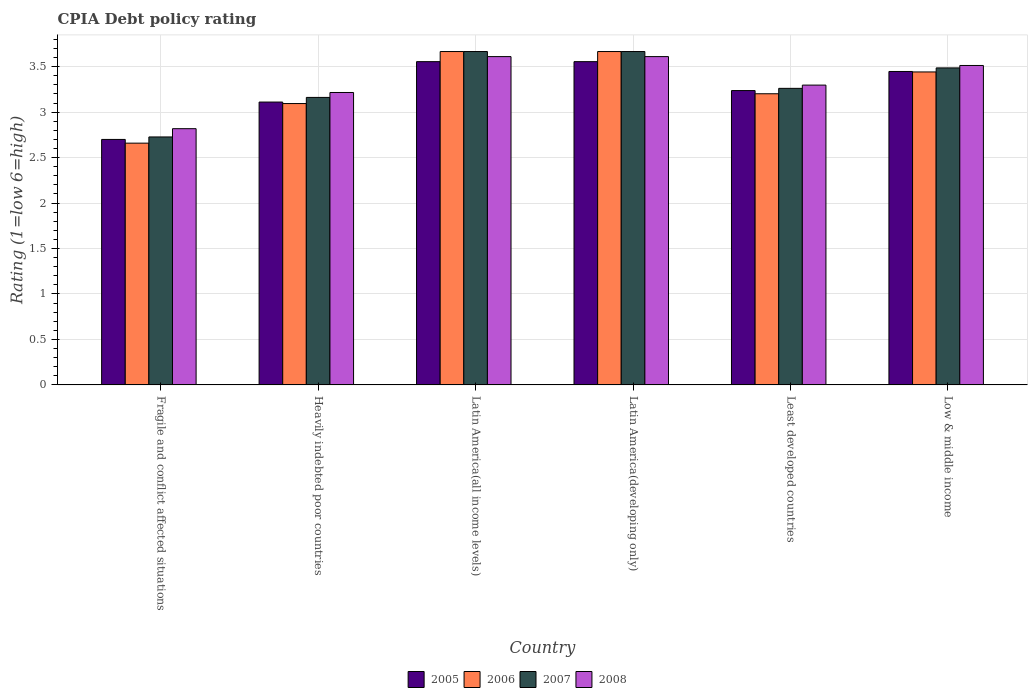How many groups of bars are there?
Give a very brief answer. 6. Are the number of bars per tick equal to the number of legend labels?
Keep it short and to the point. Yes. How many bars are there on the 1st tick from the left?
Your response must be concise. 4. What is the label of the 5th group of bars from the left?
Offer a terse response. Least developed countries. In how many cases, is the number of bars for a given country not equal to the number of legend labels?
Offer a very short reply. 0. What is the CPIA rating in 2006 in Heavily indebted poor countries?
Your answer should be compact. 3.09. Across all countries, what is the maximum CPIA rating in 2005?
Make the answer very short. 3.56. Across all countries, what is the minimum CPIA rating in 2007?
Provide a succinct answer. 2.73. In which country was the CPIA rating in 2008 maximum?
Provide a short and direct response. Latin America(all income levels). In which country was the CPIA rating in 2007 minimum?
Your response must be concise. Fragile and conflict affected situations. What is the total CPIA rating in 2008 in the graph?
Your answer should be compact. 20.07. What is the difference between the CPIA rating in 2007 in Latin America(all income levels) and that in Least developed countries?
Provide a succinct answer. 0.4. What is the difference between the CPIA rating in 2007 in Heavily indebted poor countries and the CPIA rating in 2006 in Fragile and conflict affected situations?
Provide a succinct answer. 0.5. What is the average CPIA rating in 2008 per country?
Offer a terse response. 3.34. What is the difference between the CPIA rating of/in 2006 and CPIA rating of/in 2005 in Least developed countries?
Your answer should be compact. -0.04. What is the ratio of the CPIA rating in 2005 in Heavily indebted poor countries to that in Latin America(developing only)?
Make the answer very short. 0.87. Is the CPIA rating in 2005 in Heavily indebted poor countries less than that in Latin America(developing only)?
Give a very brief answer. Yes. What is the difference between the highest and the second highest CPIA rating in 2008?
Provide a succinct answer. -0.1. What is the difference between the highest and the lowest CPIA rating in 2005?
Your response must be concise. 0.86. Is the sum of the CPIA rating in 2008 in Least developed countries and Low & middle income greater than the maximum CPIA rating in 2007 across all countries?
Your answer should be compact. Yes. Is it the case that in every country, the sum of the CPIA rating in 2008 and CPIA rating in 2007 is greater than the sum of CPIA rating in 2006 and CPIA rating in 2005?
Offer a very short reply. No. What does the 4th bar from the left in Low & middle income represents?
Make the answer very short. 2008. Are all the bars in the graph horizontal?
Your answer should be very brief. No. Are the values on the major ticks of Y-axis written in scientific E-notation?
Keep it short and to the point. No. Does the graph contain any zero values?
Give a very brief answer. No. Does the graph contain grids?
Make the answer very short. Yes. How many legend labels are there?
Offer a very short reply. 4. What is the title of the graph?
Offer a terse response. CPIA Debt policy rating. Does "1979" appear as one of the legend labels in the graph?
Ensure brevity in your answer.  No. What is the Rating (1=low 6=high) of 2006 in Fragile and conflict affected situations?
Provide a succinct answer. 2.66. What is the Rating (1=low 6=high) in 2007 in Fragile and conflict affected situations?
Ensure brevity in your answer.  2.73. What is the Rating (1=low 6=high) of 2008 in Fragile and conflict affected situations?
Offer a terse response. 2.82. What is the Rating (1=low 6=high) of 2005 in Heavily indebted poor countries?
Your response must be concise. 3.11. What is the Rating (1=low 6=high) of 2006 in Heavily indebted poor countries?
Offer a very short reply. 3.09. What is the Rating (1=low 6=high) of 2007 in Heavily indebted poor countries?
Offer a terse response. 3.16. What is the Rating (1=low 6=high) of 2008 in Heavily indebted poor countries?
Offer a very short reply. 3.22. What is the Rating (1=low 6=high) of 2005 in Latin America(all income levels)?
Provide a succinct answer. 3.56. What is the Rating (1=low 6=high) in 2006 in Latin America(all income levels)?
Make the answer very short. 3.67. What is the Rating (1=low 6=high) in 2007 in Latin America(all income levels)?
Your answer should be very brief. 3.67. What is the Rating (1=low 6=high) in 2008 in Latin America(all income levels)?
Provide a short and direct response. 3.61. What is the Rating (1=low 6=high) in 2005 in Latin America(developing only)?
Your answer should be very brief. 3.56. What is the Rating (1=low 6=high) of 2006 in Latin America(developing only)?
Your answer should be very brief. 3.67. What is the Rating (1=low 6=high) of 2007 in Latin America(developing only)?
Offer a terse response. 3.67. What is the Rating (1=low 6=high) of 2008 in Latin America(developing only)?
Your answer should be compact. 3.61. What is the Rating (1=low 6=high) in 2005 in Least developed countries?
Your answer should be compact. 3.24. What is the Rating (1=low 6=high) of 2006 in Least developed countries?
Your response must be concise. 3.2. What is the Rating (1=low 6=high) in 2007 in Least developed countries?
Keep it short and to the point. 3.26. What is the Rating (1=low 6=high) of 2008 in Least developed countries?
Offer a terse response. 3.3. What is the Rating (1=low 6=high) in 2005 in Low & middle income?
Ensure brevity in your answer.  3.45. What is the Rating (1=low 6=high) of 2006 in Low & middle income?
Your answer should be compact. 3.44. What is the Rating (1=low 6=high) in 2007 in Low & middle income?
Your response must be concise. 3.49. What is the Rating (1=low 6=high) of 2008 in Low & middle income?
Offer a very short reply. 3.51. Across all countries, what is the maximum Rating (1=low 6=high) in 2005?
Ensure brevity in your answer.  3.56. Across all countries, what is the maximum Rating (1=low 6=high) in 2006?
Provide a succinct answer. 3.67. Across all countries, what is the maximum Rating (1=low 6=high) of 2007?
Provide a succinct answer. 3.67. Across all countries, what is the maximum Rating (1=low 6=high) of 2008?
Offer a terse response. 3.61. Across all countries, what is the minimum Rating (1=low 6=high) in 2006?
Provide a short and direct response. 2.66. Across all countries, what is the minimum Rating (1=low 6=high) of 2007?
Your response must be concise. 2.73. Across all countries, what is the minimum Rating (1=low 6=high) of 2008?
Ensure brevity in your answer.  2.82. What is the total Rating (1=low 6=high) in 2005 in the graph?
Provide a short and direct response. 19.61. What is the total Rating (1=low 6=high) of 2006 in the graph?
Give a very brief answer. 19.73. What is the total Rating (1=low 6=high) in 2007 in the graph?
Give a very brief answer. 19.97. What is the total Rating (1=low 6=high) in 2008 in the graph?
Your response must be concise. 20.07. What is the difference between the Rating (1=low 6=high) in 2005 in Fragile and conflict affected situations and that in Heavily indebted poor countries?
Keep it short and to the point. -0.41. What is the difference between the Rating (1=low 6=high) in 2006 in Fragile and conflict affected situations and that in Heavily indebted poor countries?
Offer a very short reply. -0.44. What is the difference between the Rating (1=low 6=high) in 2007 in Fragile and conflict affected situations and that in Heavily indebted poor countries?
Keep it short and to the point. -0.43. What is the difference between the Rating (1=low 6=high) of 2008 in Fragile and conflict affected situations and that in Heavily indebted poor countries?
Your answer should be compact. -0.4. What is the difference between the Rating (1=low 6=high) in 2005 in Fragile and conflict affected situations and that in Latin America(all income levels)?
Your answer should be compact. -0.86. What is the difference between the Rating (1=low 6=high) of 2006 in Fragile and conflict affected situations and that in Latin America(all income levels)?
Keep it short and to the point. -1.01. What is the difference between the Rating (1=low 6=high) in 2007 in Fragile and conflict affected situations and that in Latin America(all income levels)?
Keep it short and to the point. -0.94. What is the difference between the Rating (1=low 6=high) in 2008 in Fragile and conflict affected situations and that in Latin America(all income levels)?
Give a very brief answer. -0.79. What is the difference between the Rating (1=low 6=high) in 2005 in Fragile and conflict affected situations and that in Latin America(developing only)?
Provide a succinct answer. -0.86. What is the difference between the Rating (1=low 6=high) of 2006 in Fragile and conflict affected situations and that in Latin America(developing only)?
Give a very brief answer. -1.01. What is the difference between the Rating (1=low 6=high) in 2007 in Fragile and conflict affected situations and that in Latin America(developing only)?
Provide a succinct answer. -0.94. What is the difference between the Rating (1=low 6=high) of 2008 in Fragile and conflict affected situations and that in Latin America(developing only)?
Offer a very short reply. -0.79. What is the difference between the Rating (1=low 6=high) in 2005 in Fragile and conflict affected situations and that in Least developed countries?
Keep it short and to the point. -0.54. What is the difference between the Rating (1=low 6=high) of 2006 in Fragile and conflict affected situations and that in Least developed countries?
Your answer should be very brief. -0.54. What is the difference between the Rating (1=low 6=high) in 2007 in Fragile and conflict affected situations and that in Least developed countries?
Your response must be concise. -0.53. What is the difference between the Rating (1=low 6=high) of 2008 in Fragile and conflict affected situations and that in Least developed countries?
Your answer should be very brief. -0.48. What is the difference between the Rating (1=low 6=high) in 2005 in Fragile and conflict affected situations and that in Low & middle income?
Your answer should be compact. -0.75. What is the difference between the Rating (1=low 6=high) of 2006 in Fragile and conflict affected situations and that in Low & middle income?
Offer a terse response. -0.78. What is the difference between the Rating (1=low 6=high) in 2007 in Fragile and conflict affected situations and that in Low & middle income?
Offer a very short reply. -0.76. What is the difference between the Rating (1=low 6=high) in 2008 in Fragile and conflict affected situations and that in Low & middle income?
Give a very brief answer. -0.7. What is the difference between the Rating (1=low 6=high) of 2005 in Heavily indebted poor countries and that in Latin America(all income levels)?
Ensure brevity in your answer.  -0.44. What is the difference between the Rating (1=low 6=high) in 2006 in Heavily indebted poor countries and that in Latin America(all income levels)?
Your response must be concise. -0.57. What is the difference between the Rating (1=low 6=high) in 2007 in Heavily indebted poor countries and that in Latin America(all income levels)?
Your response must be concise. -0.5. What is the difference between the Rating (1=low 6=high) in 2008 in Heavily indebted poor countries and that in Latin America(all income levels)?
Keep it short and to the point. -0.39. What is the difference between the Rating (1=low 6=high) in 2005 in Heavily indebted poor countries and that in Latin America(developing only)?
Offer a very short reply. -0.44. What is the difference between the Rating (1=low 6=high) in 2006 in Heavily indebted poor countries and that in Latin America(developing only)?
Give a very brief answer. -0.57. What is the difference between the Rating (1=low 6=high) of 2007 in Heavily indebted poor countries and that in Latin America(developing only)?
Offer a terse response. -0.5. What is the difference between the Rating (1=low 6=high) in 2008 in Heavily indebted poor countries and that in Latin America(developing only)?
Ensure brevity in your answer.  -0.39. What is the difference between the Rating (1=low 6=high) of 2005 in Heavily indebted poor countries and that in Least developed countries?
Ensure brevity in your answer.  -0.13. What is the difference between the Rating (1=low 6=high) of 2006 in Heavily indebted poor countries and that in Least developed countries?
Your response must be concise. -0.11. What is the difference between the Rating (1=low 6=high) of 2007 in Heavily indebted poor countries and that in Least developed countries?
Offer a very short reply. -0.1. What is the difference between the Rating (1=low 6=high) in 2008 in Heavily indebted poor countries and that in Least developed countries?
Ensure brevity in your answer.  -0.08. What is the difference between the Rating (1=low 6=high) of 2005 in Heavily indebted poor countries and that in Low & middle income?
Provide a short and direct response. -0.34. What is the difference between the Rating (1=low 6=high) in 2006 in Heavily indebted poor countries and that in Low & middle income?
Ensure brevity in your answer.  -0.35. What is the difference between the Rating (1=low 6=high) of 2007 in Heavily indebted poor countries and that in Low & middle income?
Provide a short and direct response. -0.32. What is the difference between the Rating (1=low 6=high) in 2008 in Heavily indebted poor countries and that in Low & middle income?
Provide a succinct answer. -0.3. What is the difference between the Rating (1=low 6=high) in 2006 in Latin America(all income levels) and that in Latin America(developing only)?
Ensure brevity in your answer.  0. What is the difference between the Rating (1=low 6=high) in 2005 in Latin America(all income levels) and that in Least developed countries?
Keep it short and to the point. 0.32. What is the difference between the Rating (1=low 6=high) of 2006 in Latin America(all income levels) and that in Least developed countries?
Ensure brevity in your answer.  0.46. What is the difference between the Rating (1=low 6=high) in 2007 in Latin America(all income levels) and that in Least developed countries?
Your response must be concise. 0.4. What is the difference between the Rating (1=low 6=high) in 2008 in Latin America(all income levels) and that in Least developed countries?
Keep it short and to the point. 0.31. What is the difference between the Rating (1=low 6=high) in 2005 in Latin America(all income levels) and that in Low & middle income?
Your answer should be compact. 0.11. What is the difference between the Rating (1=low 6=high) of 2006 in Latin America(all income levels) and that in Low & middle income?
Offer a terse response. 0.22. What is the difference between the Rating (1=low 6=high) of 2007 in Latin America(all income levels) and that in Low & middle income?
Provide a short and direct response. 0.18. What is the difference between the Rating (1=low 6=high) of 2008 in Latin America(all income levels) and that in Low & middle income?
Make the answer very short. 0.1. What is the difference between the Rating (1=low 6=high) in 2005 in Latin America(developing only) and that in Least developed countries?
Give a very brief answer. 0.32. What is the difference between the Rating (1=low 6=high) in 2006 in Latin America(developing only) and that in Least developed countries?
Offer a terse response. 0.46. What is the difference between the Rating (1=low 6=high) of 2007 in Latin America(developing only) and that in Least developed countries?
Your response must be concise. 0.4. What is the difference between the Rating (1=low 6=high) in 2008 in Latin America(developing only) and that in Least developed countries?
Your answer should be very brief. 0.31. What is the difference between the Rating (1=low 6=high) of 2005 in Latin America(developing only) and that in Low & middle income?
Offer a very short reply. 0.11. What is the difference between the Rating (1=low 6=high) of 2006 in Latin America(developing only) and that in Low & middle income?
Your answer should be very brief. 0.22. What is the difference between the Rating (1=low 6=high) in 2007 in Latin America(developing only) and that in Low & middle income?
Your answer should be compact. 0.18. What is the difference between the Rating (1=low 6=high) of 2008 in Latin America(developing only) and that in Low & middle income?
Give a very brief answer. 0.1. What is the difference between the Rating (1=low 6=high) of 2005 in Least developed countries and that in Low & middle income?
Ensure brevity in your answer.  -0.21. What is the difference between the Rating (1=low 6=high) in 2006 in Least developed countries and that in Low & middle income?
Provide a succinct answer. -0.24. What is the difference between the Rating (1=low 6=high) of 2007 in Least developed countries and that in Low & middle income?
Provide a succinct answer. -0.22. What is the difference between the Rating (1=low 6=high) in 2008 in Least developed countries and that in Low & middle income?
Offer a terse response. -0.22. What is the difference between the Rating (1=low 6=high) in 2005 in Fragile and conflict affected situations and the Rating (1=low 6=high) in 2006 in Heavily indebted poor countries?
Provide a short and direct response. -0.39. What is the difference between the Rating (1=low 6=high) in 2005 in Fragile and conflict affected situations and the Rating (1=low 6=high) in 2007 in Heavily indebted poor countries?
Provide a succinct answer. -0.46. What is the difference between the Rating (1=low 6=high) in 2005 in Fragile and conflict affected situations and the Rating (1=low 6=high) in 2008 in Heavily indebted poor countries?
Your answer should be compact. -0.52. What is the difference between the Rating (1=low 6=high) of 2006 in Fragile and conflict affected situations and the Rating (1=low 6=high) of 2007 in Heavily indebted poor countries?
Keep it short and to the point. -0.5. What is the difference between the Rating (1=low 6=high) in 2006 in Fragile and conflict affected situations and the Rating (1=low 6=high) in 2008 in Heavily indebted poor countries?
Offer a very short reply. -0.56. What is the difference between the Rating (1=low 6=high) in 2007 in Fragile and conflict affected situations and the Rating (1=low 6=high) in 2008 in Heavily indebted poor countries?
Keep it short and to the point. -0.49. What is the difference between the Rating (1=low 6=high) of 2005 in Fragile and conflict affected situations and the Rating (1=low 6=high) of 2006 in Latin America(all income levels)?
Offer a terse response. -0.97. What is the difference between the Rating (1=low 6=high) in 2005 in Fragile and conflict affected situations and the Rating (1=low 6=high) in 2007 in Latin America(all income levels)?
Offer a very short reply. -0.97. What is the difference between the Rating (1=low 6=high) of 2005 in Fragile and conflict affected situations and the Rating (1=low 6=high) of 2008 in Latin America(all income levels)?
Give a very brief answer. -0.91. What is the difference between the Rating (1=low 6=high) of 2006 in Fragile and conflict affected situations and the Rating (1=low 6=high) of 2007 in Latin America(all income levels)?
Keep it short and to the point. -1.01. What is the difference between the Rating (1=low 6=high) in 2006 in Fragile and conflict affected situations and the Rating (1=low 6=high) in 2008 in Latin America(all income levels)?
Provide a short and direct response. -0.95. What is the difference between the Rating (1=low 6=high) in 2007 in Fragile and conflict affected situations and the Rating (1=low 6=high) in 2008 in Latin America(all income levels)?
Provide a succinct answer. -0.88. What is the difference between the Rating (1=low 6=high) of 2005 in Fragile and conflict affected situations and the Rating (1=low 6=high) of 2006 in Latin America(developing only)?
Make the answer very short. -0.97. What is the difference between the Rating (1=low 6=high) in 2005 in Fragile and conflict affected situations and the Rating (1=low 6=high) in 2007 in Latin America(developing only)?
Your answer should be very brief. -0.97. What is the difference between the Rating (1=low 6=high) in 2005 in Fragile and conflict affected situations and the Rating (1=low 6=high) in 2008 in Latin America(developing only)?
Keep it short and to the point. -0.91. What is the difference between the Rating (1=low 6=high) in 2006 in Fragile and conflict affected situations and the Rating (1=low 6=high) in 2007 in Latin America(developing only)?
Ensure brevity in your answer.  -1.01. What is the difference between the Rating (1=low 6=high) in 2006 in Fragile and conflict affected situations and the Rating (1=low 6=high) in 2008 in Latin America(developing only)?
Your response must be concise. -0.95. What is the difference between the Rating (1=low 6=high) in 2007 in Fragile and conflict affected situations and the Rating (1=low 6=high) in 2008 in Latin America(developing only)?
Your answer should be compact. -0.88. What is the difference between the Rating (1=low 6=high) of 2005 in Fragile and conflict affected situations and the Rating (1=low 6=high) of 2006 in Least developed countries?
Provide a short and direct response. -0.5. What is the difference between the Rating (1=low 6=high) in 2005 in Fragile and conflict affected situations and the Rating (1=low 6=high) in 2007 in Least developed countries?
Your answer should be very brief. -0.56. What is the difference between the Rating (1=low 6=high) of 2005 in Fragile and conflict affected situations and the Rating (1=low 6=high) of 2008 in Least developed countries?
Your answer should be compact. -0.6. What is the difference between the Rating (1=low 6=high) of 2006 in Fragile and conflict affected situations and the Rating (1=low 6=high) of 2007 in Least developed countries?
Ensure brevity in your answer.  -0.6. What is the difference between the Rating (1=low 6=high) in 2006 in Fragile and conflict affected situations and the Rating (1=low 6=high) in 2008 in Least developed countries?
Keep it short and to the point. -0.64. What is the difference between the Rating (1=low 6=high) in 2007 in Fragile and conflict affected situations and the Rating (1=low 6=high) in 2008 in Least developed countries?
Make the answer very short. -0.57. What is the difference between the Rating (1=low 6=high) of 2005 in Fragile and conflict affected situations and the Rating (1=low 6=high) of 2006 in Low & middle income?
Keep it short and to the point. -0.74. What is the difference between the Rating (1=low 6=high) of 2005 in Fragile and conflict affected situations and the Rating (1=low 6=high) of 2007 in Low & middle income?
Ensure brevity in your answer.  -0.79. What is the difference between the Rating (1=low 6=high) in 2005 in Fragile and conflict affected situations and the Rating (1=low 6=high) in 2008 in Low & middle income?
Give a very brief answer. -0.81. What is the difference between the Rating (1=low 6=high) in 2006 in Fragile and conflict affected situations and the Rating (1=low 6=high) in 2007 in Low & middle income?
Offer a terse response. -0.83. What is the difference between the Rating (1=low 6=high) of 2006 in Fragile and conflict affected situations and the Rating (1=low 6=high) of 2008 in Low & middle income?
Keep it short and to the point. -0.85. What is the difference between the Rating (1=low 6=high) in 2007 in Fragile and conflict affected situations and the Rating (1=low 6=high) in 2008 in Low & middle income?
Your answer should be very brief. -0.79. What is the difference between the Rating (1=low 6=high) in 2005 in Heavily indebted poor countries and the Rating (1=low 6=high) in 2006 in Latin America(all income levels)?
Ensure brevity in your answer.  -0.56. What is the difference between the Rating (1=low 6=high) of 2005 in Heavily indebted poor countries and the Rating (1=low 6=high) of 2007 in Latin America(all income levels)?
Make the answer very short. -0.56. What is the difference between the Rating (1=low 6=high) in 2006 in Heavily indebted poor countries and the Rating (1=low 6=high) in 2007 in Latin America(all income levels)?
Offer a very short reply. -0.57. What is the difference between the Rating (1=low 6=high) in 2006 in Heavily indebted poor countries and the Rating (1=low 6=high) in 2008 in Latin America(all income levels)?
Provide a short and direct response. -0.52. What is the difference between the Rating (1=low 6=high) of 2007 in Heavily indebted poor countries and the Rating (1=low 6=high) of 2008 in Latin America(all income levels)?
Provide a short and direct response. -0.45. What is the difference between the Rating (1=low 6=high) in 2005 in Heavily indebted poor countries and the Rating (1=low 6=high) in 2006 in Latin America(developing only)?
Provide a succinct answer. -0.56. What is the difference between the Rating (1=low 6=high) in 2005 in Heavily indebted poor countries and the Rating (1=low 6=high) in 2007 in Latin America(developing only)?
Give a very brief answer. -0.56. What is the difference between the Rating (1=low 6=high) of 2006 in Heavily indebted poor countries and the Rating (1=low 6=high) of 2007 in Latin America(developing only)?
Your answer should be compact. -0.57. What is the difference between the Rating (1=low 6=high) of 2006 in Heavily indebted poor countries and the Rating (1=low 6=high) of 2008 in Latin America(developing only)?
Your answer should be compact. -0.52. What is the difference between the Rating (1=low 6=high) in 2007 in Heavily indebted poor countries and the Rating (1=low 6=high) in 2008 in Latin America(developing only)?
Your answer should be compact. -0.45. What is the difference between the Rating (1=low 6=high) in 2005 in Heavily indebted poor countries and the Rating (1=low 6=high) in 2006 in Least developed countries?
Ensure brevity in your answer.  -0.09. What is the difference between the Rating (1=low 6=high) in 2005 in Heavily indebted poor countries and the Rating (1=low 6=high) in 2007 in Least developed countries?
Your answer should be compact. -0.15. What is the difference between the Rating (1=low 6=high) of 2005 in Heavily indebted poor countries and the Rating (1=low 6=high) of 2008 in Least developed countries?
Make the answer very short. -0.19. What is the difference between the Rating (1=low 6=high) of 2006 in Heavily indebted poor countries and the Rating (1=low 6=high) of 2007 in Least developed countries?
Your answer should be compact. -0.17. What is the difference between the Rating (1=low 6=high) of 2006 in Heavily indebted poor countries and the Rating (1=low 6=high) of 2008 in Least developed countries?
Your answer should be compact. -0.2. What is the difference between the Rating (1=low 6=high) in 2007 in Heavily indebted poor countries and the Rating (1=low 6=high) in 2008 in Least developed countries?
Make the answer very short. -0.14. What is the difference between the Rating (1=low 6=high) in 2005 in Heavily indebted poor countries and the Rating (1=low 6=high) in 2006 in Low & middle income?
Provide a short and direct response. -0.33. What is the difference between the Rating (1=low 6=high) of 2005 in Heavily indebted poor countries and the Rating (1=low 6=high) of 2007 in Low & middle income?
Make the answer very short. -0.38. What is the difference between the Rating (1=low 6=high) of 2005 in Heavily indebted poor countries and the Rating (1=low 6=high) of 2008 in Low & middle income?
Give a very brief answer. -0.4. What is the difference between the Rating (1=low 6=high) of 2006 in Heavily indebted poor countries and the Rating (1=low 6=high) of 2007 in Low & middle income?
Ensure brevity in your answer.  -0.39. What is the difference between the Rating (1=low 6=high) of 2006 in Heavily indebted poor countries and the Rating (1=low 6=high) of 2008 in Low & middle income?
Your answer should be compact. -0.42. What is the difference between the Rating (1=low 6=high) in 2007 in Heavily indebted poor countries and the Rating (1=low 6=high) in 2008 in Low & middle income?
Make the answer very short. -0.35. What is the difference between the Rating (1=low 6=high) in 2005 in Latin America(all income levels) and the Rating (1=low 6=high) in 2006 in Latin America(developing only)?
Your answer should be compact. -0.11. What is the difference between the Rating (1=low 6=high) of 2005 in Latin America(all income levels) and the Rating (1=low 6=high) of 2007 in Latin America(developing only)?
Provide a short and direct response. -0.11. What is the difference between the Rating (1=low 6=high) in 2005 in Latin America(all income levels) and the Rating (1=low 6=high) in 2008 in Latin America(developing only)?
Provide a short and direct response. -0.06. What is the difference between the Rating (1=low 6=high) in 2006 in Latin America(all income levels) and the Rating (1=low 6=high) in 2007 in Latin America(developing only)?
Provide a succinct answer. 0. What is the difference between the Rating (1=low 6=high) in 2006 in Latin America(all income levels) and the Rating (1=low 6=high) in 2008 in Latin America(developing only)?
Offer a terse response. 0.06. What is the difference between the Rating (1=low 6=high) in 2007 in Latin America(all income levels) and the Rating (1=low 6=high) in 2008 in Latin America(developing only)?
Ensure brevity in your answer.  0.06. What is the difference between the Rating (1=low 6=high) in 2005 in Latin America(all income levels) and the Rating (1=low 6=high) in 2006 in Least developed countries?
Ensure brevity in your answer.  0.35. What is the difference between the Rating (1=low 6=high) of 2005 in Latin America(all income levels) and the Rating (1=low 6=high) of 2007 in Least developed countries?
Give a very brief answer. 0.29. What is the difference between the Rating (1=low 6=high) in 2005 in Latin America(all income levels) and the Rating (1=low 6=high) in 2008 in Least developed countries?
Keep it short and to the point. 0.26. What is the difference between the Rating (1=low 6=high) of 2006 in Latin America(all income levels) and the Rating (1=low 6=high) of 2007 in Least developed countries?
Make the answer very short. 0.4. What is the difference between the Rating (1=low 6=high) of 2006 in Latin America(all income levels) and the Rating (1=low 6=high) of 2008 in Least developed countries?
Keep it short and to the point. 0.37. What is the difference between the Rating (1=low 6=high) of 2007 in Latin America(all income levels) and the Rating (1=low 6=high) of 2008 in Least developed countries?
Your answer should be compact. 0.37. What is the difference between the Rating (1=low 6=high) of 2005 in Latin America(all income levels) and the Rating (1=low 6=high) of 2006 in Low & middle income?
Provide a short and direct response. 0.11. What is the difference between the Rating (1=low 6=high) of 2005 in Latin America(all income levels) and the Rating (1=low 6=high) of 2007 in Low & middle income?
Give a very brief answer. 0.07. What is the difference between the Rating (1=low 6=high) in 2005 in Latin America(all income levels) and the Rating (1=low 6=high) in 2008 in Low & middle income?
Your answer should be very brief. 0.04. What is the difference between the Rating (1=low 6=high) in 2006 in Latin America(all income levels) and the Rating (1=low 6=high) in 2007 in Low & middle income?
Provide a short and direct response. 0.18. What is the difference between the Rating (1=low 6=high) of 2006 in Latin America(all income levels) and the Rating (1=low 6=high) of 2008 in Low & middle income?
Offer a very short reply. 0.15. What is the difference between the Rating (1=low 6=high) of 2007 in Latin America(all income levels) and the Rating (1=low 6=high) of 2008 in Low & middle income?
Your answer should be compact. 0.15. What is the difference between the Rating (1=low 6=high) of 2005 in Latin America(developing only) and the Rating (1=low 6=high) of 2006 in Least developed countries?
Ensure brevity in your answer.  0.35. What is the difference between the Rating (1=low 6=high) of 2005 in Latin America(developing only) and the Rating (1=low 6=high) of 2007 in Least developed countries?
Offer a terse response. 0.29. What is the difference between the Rating (1=low 6=high) of 2005 in Latin America(developing only) and the Rating (1=low 6=high) of 2008 in Least developed countries?
Your answer should be compact. 0.26. What is the difference between the Rating (1=low 6=high) in 2006 in Latin America(developing only) and the Rating (1=low 6=high) in 2007 in Least developed countries?
Your answer should be compact. 0.4. What is the difference between the Rating (1=low 6=high) of 2006 in Latin America(developing only) and the Rating (1=low 6=high) of 2008 in Least developed countries?
Your answer should be compact. 0.37. What is the difference between the Rating (1=low 6=high) of 2007 in Latin America(developing only) and the Rating (1=low 6=high) of 2008 in Least developed countries?
Your answer should be compact. 0.37. What is the difference between the Rating (1=low 6=high) of 2005 in Latin America(developing only) and the Rating (1=low 6=high) of 2006 in Low & middle income?
Ensure brevity in your answer.  0.11. What is the difference between the Rating (1=low 6=high) of 2005 in Latin America(developing only) and the Rating (1=low 6=high) of 2007 in Low & middle income?
Make the answer very short. 0.07. What is the difference between the Rating (1=low 6=high) in 2005 in Latin America(developing only) and the Rating (1=low 6=high) in 2008 in Low & middle income?
Your answer should be compact. 0.04. What is the difference between the Rating (1=low 6=high) in 2006 in Latin America(developing only) and the Rating (1=low 6=high) in 2007 in Low & middle income?
Provide a succinct answer. 0.18. What is the difference between the Rating (1=low 6=high) in 2006 in Latin America(developing only) and the Rating (1=low 6=high) in 2008 in Low & middle income?
Offer a very short reply. 0.15. What is the difference between the Rating (1=low 6=high) in 2007 in Latin America(developing only) and the Rating (1=low 6=high) in 2008 in Low & middle income?
Your answer should be very brief. 0.15. What is the difference between the Rating (1=low 6=high) of 2005 in Least developed countries and the Rating (1=low 6=high) of 2006 in Low & middle income?
Ensure brevity in your answer.  -0.2. What is the difference between the Rating (1=low 6=high) in 2005 in Least developed countries and the Rating (1=low 6=high) in 2007 in Low & middle income?
Offer a terse response. -0.25. What is the difference between the Rating (1=low 6=high) of 2005 in Least developed countries and the Rating (1=low 6=high) of 2008 in Low & middle income?
Keep it short and to the point. -0.28. What is the difference between the Rating (1=low 6=high) in 2006 in Least developed countries and the Rating (1=low 6=high) in 2007 in Low & middle income?
Your answer should be compact. -0.28. What is the difference between the Rating (1=low 6=high) in 2006 in Least developed countries and the Rating (1=low 6=high) in 2008 in Low & middle income?
Provide a short and direct response. -0.31. What is the difference between the Rating (1=low 6=high) of 2007 in Least developed countries and the Rating (1=low 6=high) of 2008 in Low & middle income?
Offer a very short reply. -0.25. What is the average Rating (1=low 6=high) in 2005 per country?
Provide a short and direct response. 3.27. What is the average Rating (1=low 6=high) in 2006 per country?
Your answer should be compact. 3.29. What is the average Rating (1=low 6=high) in 2007 per country?
Provide a short and direct response. 3.33. What is the average Rating (1=low 6=high) in 2008 per country?
Your answer should be very brief. 3.34. What is the difference between the Rating (1=low 6=high) in 2005 and Rating (1=low 6=high) in 2006 in Fragile and conflict affected situations?
Your answer should be very brief. 0.04. What is the difference between the Rating (1=low 6=high) in 2005 and Rating (1=low 6=high) in 2007 in Fragile and conflict affected situations?
Make the answer very short. -0.03. What is the difference between the Rating (1=low 6=high) in 2005 and Rating (1=low 6=high) in 2008 in Fragile and conflict affected situations?
Keep it short and to the point. -0.12. What is the difference between the Rating (1=low 6=high) of 2006 and Rating (1=low 6=high) of 2007 in Fragile and conflict affected situations?
Provide a succinct answer. -0.07. What is the difference between the Rating (1=low 6=high) of 2006 and Rating (1=low 6=high) of 2008 in Fragile and conflict affected situations?
Provide a succinct answer. -0.16. What is the difference between the Rating (1=low 6=high) in 2007 and Rating (1=low 6=high) in 2008 in Fragile and conflict affected situations?
Your answer should be very brief. -0.09. What is the difference between the Rating (1=low 6=high) in 2005 and Rating (1=low 6=high) in 2006 in Heavily indebted poor countries?
Make the answer very short. 0.02. What is the difference between the Rating (1=low 6=high) of 2005 and Rating (1=low 6=high) of 2007 in Heavily indebted poor countries?
Your answer should be very brief. -0.05. What is the difference between the Rating (1=low 6=high) of 2005 and Rating (1=low 6=high) of 2008 in Heavily indebted poor countries?
Provide a short and direct response. -0.11. What is the difference between the Rating (1=low 6=high) of 2006 and Rating (1=low 6=high) of 2007 in Heavily indebted poor countries?
Offer a very short reply. -0.07. What is the difference between the Rating (1=low 6=high) of 2006 and Rating (1=low 6=high) of 2008 in Heavily indebted poor countries?
Provide a succinct answer. -0.12. What is the difference between the Rating (1=low 6=high) in 2007 and Rating (1=low 6=high) in 2008 in Heavily indebted poor countries?
Your response must be concise. -0.05. What is the difference between the Rating (1=low 6=high) in 2005 and Rating (1=low 6=high) in 2006 in Latin America(all income levels)?
Make the answer very short. -0.11. What is the difference between the Rating (1=low 6=high) in 2005 and Rating (1=low 6=high) in 2007 in Latin America(all income levels)?
Ensure brevity in your answer.  -0.11. What is the difference between the Rating (1=low 6=high) of 2005 and Rating (1=low 6=high) of 2008 in Latin America(all income levels)?
Your answer should be very brief. -0.06. What is the difference between the Rating (1=low 6=high) of 2006 and Rating (1=low 6=high) of 2007 in Latin America(all income levels)?
Provide a succinct answer. 0. What is the difference between the Rating (1=low 6=high) in 2006 and Rating (1=low 6=high) in 2008 in Latin America(all income levels)?
Provide a short and direct response. 0.06. What is the difference between the Rating (1=low 6=high) in 2007 and Rating (1=low 6=high) in 2008 in Latin America(all income levels)?
Give a very brief answer. 0.06. What is the difference between the Rating (1=low 6=high) of 2005 and Rating (1=low 6=high) of 2006 in Latin America(developing only)?
Keep it short and to the point. -0.11. What is the difference between the Rating (1=low 6=high) in 2005 and Rating (1=low 6=high) in 2007 in Latin America(developing only)?
Ensure brevity in your answer.  -0.11. What is the difference between the Rating (1=low 6=high) of 2005 and Rating (1=low 6=high) of 2008 in Latin America(developing only)?
Your response must be concise. -0.06. What is the difference between the Rating (1=low 6=high) in 2006 and Rating (1=low 6=high) in 2008 in Latin America(developing only)?
Provide a succinct answer. 0.06. What is the difference between the Rating (1=low 6=high) of 2007 and Rating (1=low 6=high) of 2008 in Latin America(developing only)?
Give a very brief answer. 0.06. What is the difference between the Rating (1=low 6=high) of 2005 and Rating (1=low 6=high) of 2006 in Least developed countries?
Your answer should be compact. 0.04. What is the difference between the Rating (1=low 6=high) of 2005 and Rating (1=low 6=high) of 2007 in Least developed countries?
Give a very brief answer. -0.02. What is the difference between the Rating (1=low 6=high) in 2005 and Rating (1=low 6=high) in 2008 in Least developed countries?
Offer a very short reply. -0.06. What is the difference between the Rating (1=low 6=high) of 2006 and Rating (1=low 6=high) of 2007 in Least developed countries?
Keep it short and to the point. -0.06. What is the difference between the Rating (1=low 6=high) of 2006 and Rating (1=low 6=high) of 2008 in Least developed countries?
Offer a very short reply. -0.1. What is the difference between the Rating (1=low 6=high) of 2007 and Rating (1=low 6=high) of 2008 in Least developed countries?
Offer a terse response. -0.04. What is the difference between the Rating (1=low 6=high) in 2005 and Rating (1=low 6=high) in 2006 in Low & middle income?
Your response must be concise. 0.01. What is the difference between the Rating (1=low 6=high) in 2005 and Rating (1=low 6=high) in 2007 in Low & middle income?
Your answer should be compact. -0.04. What is the difference between the Rating (1=low 6=high) of 2005 and Rating (1=low 6=high) of 2008 in Low & middle income?
Provide a succinct answer. -0.07. What is the difference between the Rating (1=low 6=high) of 2006 and Rating (1=low 6=high) of 2007 in Low & middle income?
Your answer should be very brief. -0.04. What is the difference between the Rating (1=low 6=high) of 2006 and Rating (1=low 6=high) of 2008 in Low & middle income?
Offer a very short reply. -0.07. What is the difference between the Rating (1=low 6=high) in 2007 and Rating (1=low 6=high) in 2008 in Low & middle income?
Offer a terse response. -0.03. What is the ratio of the Rating (1=low 6=high) of 2005 in Fragile and conflict affected situations to that in Heavily indebted poor countries?
Provide a short and direct response. 0.87. What is the ratio of the Rating (1=low 6=high) in 2006 in Fragile and conflict affected situations to that in Heavily indebted poor countries?
Offer a terse response. 0.86. What is the ratio of the Rating (1=low 6=high) of 2007 in Fragile and conflict affected situations to that in Heavily indebted poor countries?
Make the answer very short. 0.86. What is the ratio of the Rating (1=low 6=high) in 2008 in Fragile and conflict affected situations to that in Heavily indebted poor countries?
Your response must be concise. 0.88. What is the ratio of the Rating (1=low 6=high) of 2005 in Fragile and conflict affected situations to that in Latin America(all income levels)?
Offer a terse response. 0.76. What is the ratio of the Rating (1=low 6=high) in 2006 in Fragile and conflict affected situations to that in Latin America(all income levels)?
Your answer should be very brief. 0.73. What is the ratio of the Rating (1=low 6=high) in 2007 in Fragile and conflict affected situations to that in Latin America(all income levels)?
Provide a short and direct response. 0.74. What is the ratio of the Rating (1=low 6=high) of 2008 in Fragile and conflict affected situations to that in Latin America(all income levels)?
Your response must be concise. 0.78. What is the ratio of the Rating (1=low 6=high) of 2005 in Fragile and conflict affected situations to that in Latin America(developing only)?
Your answer should be very brief. 0.76. What is the ratio of the Rating (1=low 6=high) in 2006 in Fragile and conflict affected situations to that in Latin America(developing only)?
Keep it short and to the point. 0.73. What is the ratio of the Rating (1=low 6=high) of 2007 in Fragile and conflict affected situations to that in Latin America(developing only)?
Offer a very short reply. 0.74. What is the ratio of the Rating (1=low 6=high) of 2008 in Fragile and conflict affected situations to that in Latin America(developing only)?
Provide a short and direct response. 0.78. What is the ratio of the Rating (1=low 6=high) of 2005 in Fragile and conflict affected situations to that in Least developed countries?
Make the answer very short. 0.83. What is the ratio of the Rating (1=low 6=high) in 2006 in Fragile and conflict affected situations to that in Least developed countries?
Your response must be concise. 0.83. What is the ratio of the Rating (1=low 6=high) of 2007 in Fragile and conflict affected situations to that in Least developed countries?
Give a very brief answer. 0.84. What is the ratio of the Rating (1=low 6=high) in 2008 in Fragile and conflict affected situations to that in Least developed countries?
Keep it short and to the point. 0.85. What is the ratio of the Rating (1=low 6=high) of 2005 in Fragile and conflict affected situations to that in Low & middle income?
Give a very brief answer. 0.78. What is the ratio of the Rating (1=low 6=high) in 2006 in Fragile and conflict affected situations to that in Low & middle income?
Offer a terse response. 0.77. What is the ratio of the Rating (1=low 6=high) in 2007 in Fragile and conflict affected situations to that in Low & middle income?
Keep it short and to the point. 0.78. What is the ratio of the Rating (1=low 6=high) of 2008 in Fragile and conflict affected situations to that in Low & middle income?
Give a very brief answer. 0.8. What is the ratio of the Rating (1=low 6=high) of 2005 in Heavily indebted poor countries to that in Latin America(all income levels)?
Keep it short and to the point. 0.88. What is the ratio of the Rating (1=low 6=high) of 2006 in Heavily indebted poor countries to that in Latin America(all income levels)?
Give a very brief answer. 0.84. What is the ratio of the Rating (1=low 6=high) of 2007 in Heavily indebted poor countries to that in Latin America(all income levels)?
Your answer should be compact. 0.86. What is the ratio of the Rating (1=low 6=high) in 2008 in Heavily indebted poor countries to that in Latin America(all income levels)?
Ensure brevity in your answer.  0.89. What is the ratio of the Rating (1=low 6=high) in 2005 in Heavily indebted poor countries to that in Latin America(developing only)?
Offer a terse response. 0.88. What is the ratio of the Rating (1=low 6=high) of 2006 in Heavily indebted poor countries to that in Latin America(developing only)?
Provide a short and direct response. 0.84. What is the ratio of the Rating (1=low 6=high) in 2007 in Heavily indebted poor countries to that in Latin America(developing only)?
Give a very brief answer. 0.86. What is the ratio of the Rating (1=low 6=high) in 2008 in Heavily indebted poor countries to that in Latin America(developing only)?
Your answer should be compact. 0.89. What is the ratio of the Rating (1=low 6=high) of 2005 in Heavily indebted poor countries to that in Least developed countries?
Offer a terse response. 0.96. What is the ratio of the Rating (1=low 6=high) in 2006 in Heavily indebted poor countries to that in Least developed countries?
Provide a short and direct response. 0.97. What is the ratio of the Rating (1=low 6=high) in 2007 in Heavily indebted poor countries to that in Least developed countries?
Offer a very short reply. 0.97. What is the ratio of the Rating (1=low 6=high) of 2008 in Heavily indebted poor countries to that in Least developed countries?
Your answer should be compact. 0.98. What is the ratio of the Rating (1=low 6=high) of 2005 in Heavily indebted poor countries to that in Low & middle income?
Your answer should be compact. 0.9. What is the ratio of the Rating (1=low 6=high) of 2006 in Heavily indebted poor countries to that in Low & middle income?
Your response must be concise. 0.9. What is the ratio of the Rating (1=low 6=high) of 2007 in Heavily indebted poor countries to that in Low & middle income?
Ensure brevity in your answer.  0.91. What is the ratio of the Rating (1=low 6=high) of 2008 in Heavily indebted poor countries to that in Low & middle income?
Keep it short and to the point. 0.92. What is the ratio of the Rating (1=low 6=high) of 2005 in Latin America(all income levels) to that in Latin America(developing only)?
Keep it short and to the point. 1. What is the ratio of the Rating (1=low 6=high) of 2006 in Latin America(all income levels) to that in Latin America(developing only)?
Your response must be concise. 1. What is the ratio of the Rating (1=low 6=high) in 2008 in Latin America(all income levels) to that in Latin America(developing only)?
Give a very brief answer. 1. What is the ratio of the Rating (1=low 6=high) of 2005 in Latin America(all income levels) to that in Least developed countries?
Offer a terse response. 1.1. What is the ratio of the Rating (1=low 6=high) of 2006 in Latin America(all income levels) to that in Least developed countries?
Your answer should be very brief. 1.15. What is the ratio of the Rating (1=low 6=high) of 2007 in Latin America(all income levels) to that in Least developed countries?
Provide a short and direct response. 1.12. What is the ratio of the Rating (1=low 6=high) of 2008 in Latin America(all income levels) to that in Least developed countries?
Your answer should be compact. 1.1. What is the ratio of the Rating (1=low 6=high) of 2005 in Latin America(all income levels) to that in Low & middle income?
Offer a very short reply. 1.03. What is the ratio of the Rating (1=low 6=high) of 2006 in Latin America(all income levels) to that in Low & middle income?
Your answer should be very brief. 1.07. What is the ratio of the Rating (1=low 6=high) in 2007 in Latin America(all income levels) to that in Low & middle income?
Give a very brief answer. 1.05. What is the ratio of the Rating (1=low 6=high) in 2008 in Latin America(all income levels) to that in Low & middle income?
Provide a succinct answer. 1.03. What is the ratio of the Rating (1=low 6=high) of 2005 in Latin America(developing only) to that in Least developed countries?
Ensure brevity in your answer.  1.1. What is the ratio of the Rating (1=low 6=high) of 2006 in Latin America(developing only) to that in Least developed countries?
Provide a short and direct response. 1.15. What is the ratio of the Rating (1=low 6=high) of 2007 in Latin America(developing only) to that in Least developed countries?
Offer a very short reply. 1.12. What is the ratio of the Rating (1=low 6=high) of 2008 in Latin America(developing only) to that in Least developed countries?
Provide a short and direct response. 1.1. What is the ratio of the Rating (1=low 6=high) of 2005 in Latin America(developing only) to that in Low & middle income?
Provide a short and direct response. 1.03. What is the ratio of the Rating (1=low 6=high) of 2006 in Latin America(developing only) to that in Low & middle income?
Ensure brevity in your answer.  1.07. What is the ratio of the Rating (1=low 6=high) in 2007 in Latin America(developing only) to that in Low & middle income?
Offer a very short reply. 1.05. What is the ratio of the Rating (1=low 6=high) in 2008 in Latin America(developing only) to that in Low & middle income?
Give a very brief answer. 1.03. What is the ratio of the Rating (1=low 6=high) of 2005 in Least developed countries to that in Low & middle income?
Keep it short and to the point. 0.94. What is the ratio of the Rating (1=low 6=high) in 2006 in Least developed countries to that in Low & middle income?
Your response must be concise. 0.93. What is the ratio of the Rating (1=low 6=high) of 2007 in Least developed countries to that in Low & middle income?
Ensure brevity in your answer.  0.94. What is the ratio of the Rating (1=low 6=high) of 2008 in Least developed countries to that in Low & middle income?
Your answer should be compact. 0.94. What is the difference between the highest and the second highest Rating (1=low 6=high) of 2005?
Your answer should be very brief. 0. What is the difference between the highest and the second highest Rating (1=low 6=high) in 2007?
Give a very brief answer. 0. What is the difference between the highest and the second highest Rating (1=low 6=high) in 2008?
Offer a terse response. 0. What is the difference between the highest and the lowest Rating (1=low 6=high) of 2005?
Your response must be concise. 0.86. What is the difference between the highest and the lowest Rating (1=low 6=high) in 2006?
Offer a very short reply. 1.01. What is the difference between the highest and the lowest Rating (1=low 6=high) of 2007?
Provide a succinct answer. 0.94. What is the difference between the highest and the lowest Rating (1=low 6=high) in 2008?
Offer a very short reply. 0.79. 